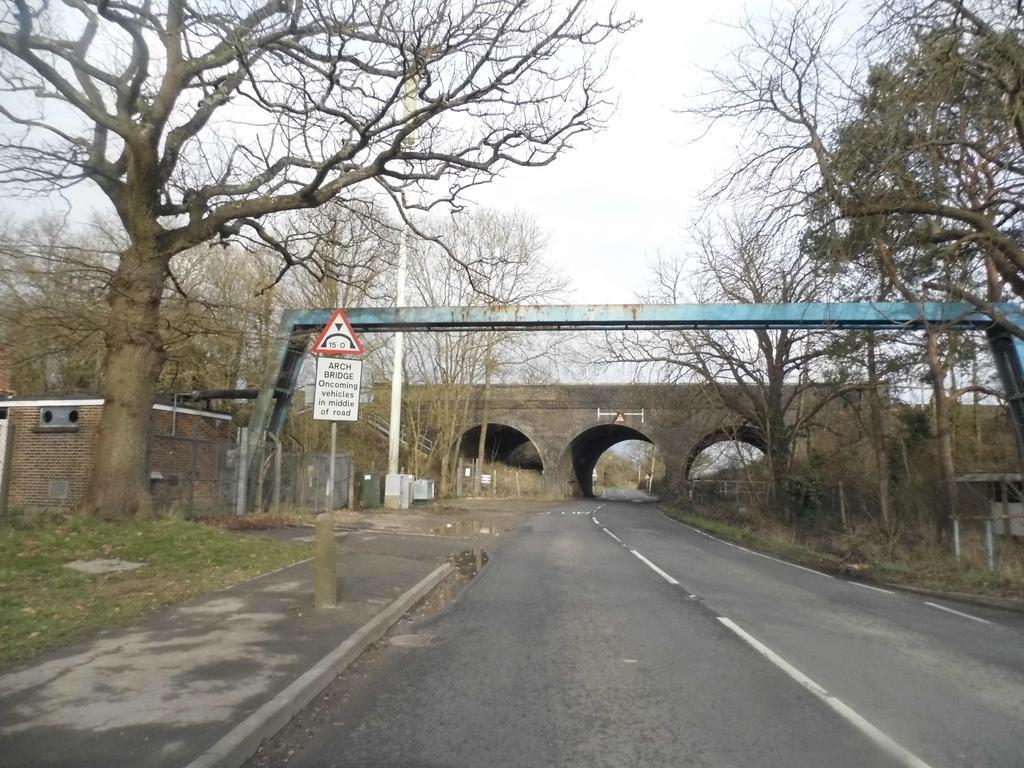Can you describe this image briefly? In this image there is a empty road with bridge, beside that there are so many trees and there is a pole with board on it. 